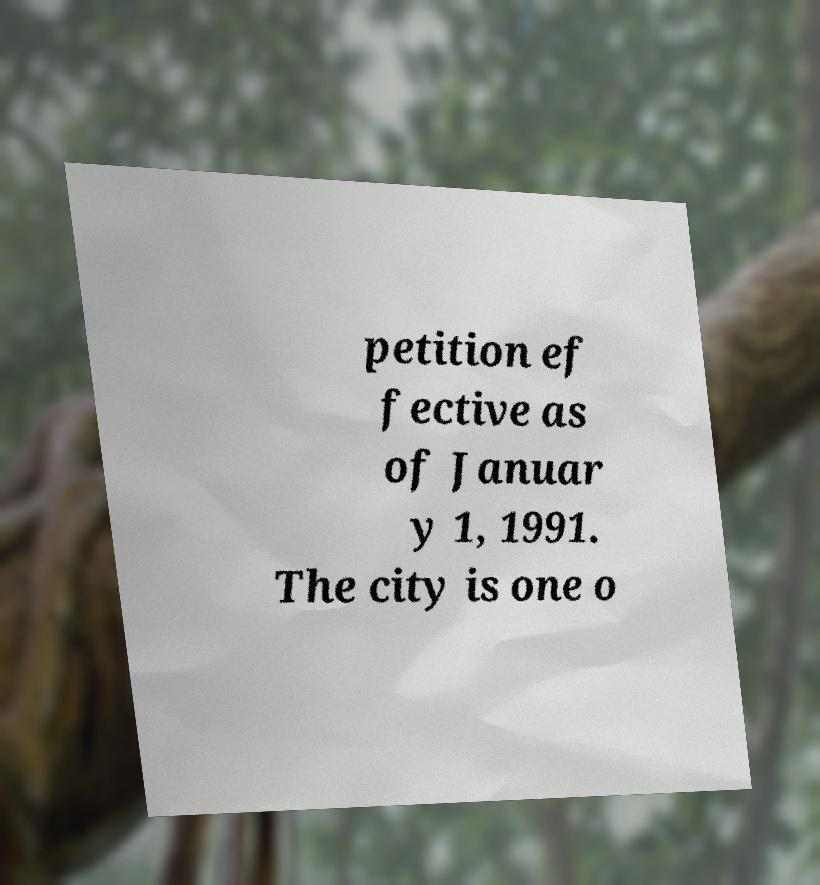Please identify and transcribe the text found in this image. petition ef fective as of Januar y 1, 1991. The city is one o 